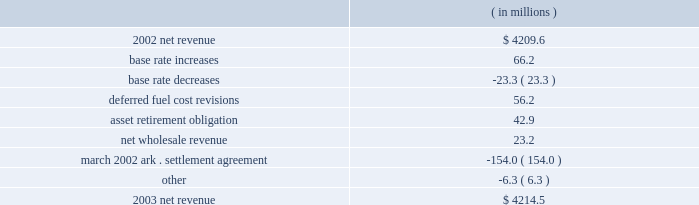Entergy corporation and subsidiaries management's financial discussion and analysis 2022 the deferral in august 2004 of $ 7.5 million of fossil plant maintenance and voluntary severance program costs at entergy new orleans as a result of a stipulation approved by the city council .
2003 compared to 2002 net revenue , which is entergy's measure of gross margin , consists of operating revenues net of : 1 ) fuel , fuel-related , and purchased power expenses and 2 ) other regulatory credits .
Following is an analysis of the change in net revenue comparing 2003 to 2002. .
Base rates increased net revenue due to base rate increases at entergy mississippi and entergy new orleans that became effective in january 2003 and june 2003 , respectively .
Entergy gulf states implemented base rate decreases in its louisiana jurisdiction effective june 2002 and january 2003 .
The january 2003 base rate decrease of $ 22.1 million had a minimal impact on net income due to a corresponding reduction in nuclear depreciation and decommissioning expenses associated with the change in accounting estimate to reflect an assumed extension of river bend's useful life .
The deferred fuel cost revisions variance was due to a revised unbilled sales pricing estimate made in december 2002 and further revision of that estimate in the first quarter of 2003 to more closely align the fuel component of that pricing with expected recoverable fuel costs at entergy louisiana .
The asset retirement obligation variance was due to the implementation of sfas 143 , "accounting for asset retirement obligations" adopted in january 2003 .
See "critical accounting estimates 2013 nuclear decommissioning costs" for more details on sfas 143 .
The increase was offset by increased depreciation and decommissioning expenses and had an insignificant effect on net income .
The increase in net wholesale revenue was primarily due to an increase in sales volume to municipal and cooperative customers .
The march 2002 settlement agreement variance reflects the absence in 2003 of the effect of recording the ice storm settlement approved by the apsc in 2002 .
This settlement resulted in previously deferred revenues at entergy arkansas per the transition cost account mechanism being recorded in net revenue in the second quarter of 2002 .
The decrease was offset by a corresponding decrease in other operation and maintenance expenses and had a minimal effect on net income .
Gross operating revenues and regulatory credits gross operating revenues include an increase in fuel cost recovery revenues of $ 682 million and $ 53 million in electric and gas sales , respectively , primarily due to higher fuel rates in 2003 resulting from increases in the market prices of purchased power and natural gas .
As such , this revenue increase was offset by increased fuel and purchased power expenses. .
What is the growth rate in net revenue in 2003 for entergy corporation? 
Computations: ((4214.5 - 4209.6) / 4209.6)
Answer: 0.00116. Entergy corporation and subsidiaries management's financial discussion and analysis 2022 the deferral in august 2004 of $ 7.5 million of fossil plant maintenance and voluntary severance program costs at entergy new orleans as a result of a stipulation approved by the city council .
2003 compared to 2002 net revenue , which is entergy's measure of gross margin , consists of operating revenues net of : 1 ) fuel , fuel-related , and purchased power expenses and 2 ) other regulatory credits .
Following is an analysis of the change in net revenue comparing 2003 to 2002. .
Base rates increased net revenue due to base rate increases at entergy mississippi and entergy new orleans that became effective in january 2003 and june 2003 , respectively .
Entergy gulf states implemented base rate decreases in its louisiana jurisdiction effective june 2002 and january 2003 .
The january 2003 base rate decrease of $ 22.1 million had a minimal impact on net income due to a corresponding reduction in nuclear depreciation and decommissioning expenses associated with the change in accounting estimate to reflect an assumed extension of river bend's useful life .
The deferred fuel cost revisions variance was due to a revised unbilled sales pricing estimate made in december 2002 and further revision of that estimate in the first quarter of 2003 to more closely align the fuel component of that pricing with expected recoverable fuel costs at entergy louisiana .
The asset retirement obligation variance was due to the implementation of sfas 143 , "accounting for asset retirement obligations" adopted in january 2003 .
See "critical accounting estimates 2013 nuclear decommissioning costs" for more details on sfas 143 .
The increase was offset by increased depreciation and decommissioning expenses and had an insignificant effect on net income .
The increase in net wholesale revenue was primarily due to an increase in sales volume to municipal and cooperative customers .
The march 2002 settlement agreement variance reflects the absence in 2003 of the effect of recording the ice storm settlement approved by the apsc in 2002 .
This settlement resulted in previously deferred revenues at entergy arkansas per the transition cost account mechanism being recorded in net revenue in the second quarter of 2002 .
The decrease was offset by a corresponding decrease in other operation and maintenance expenses and had a minimal effect on net income .
Gross operating revenues and regulatory credits gross operating revenues include an increase in fuel cost recovery revenues of $ 682 million and $ 53 million in electric and gas sales , respectively , primarily due to higher fuel rates in 2003 resulting from increases in the market prices of purchased power and natural gas .
As such , this revenue increase was offset by increased fuel and purchased power expenses. .
What is the net change in net revenue during 2003 for entergy corporation? 
Computations: (4214.5 - 4209.6)
Answer: 4.9. 